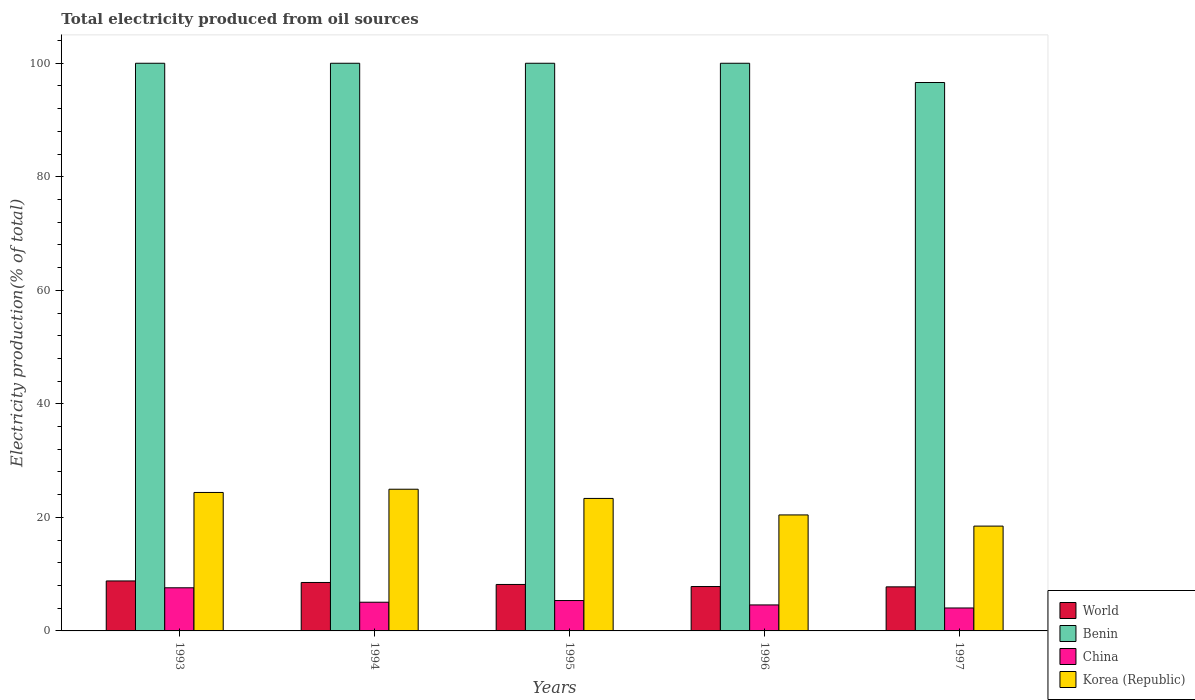How many different coloured bars are there?
Your response must be concise. 4. How many groups of bars are there?
Offer a very short reply. 5. Are the number of bars per tick equal to the number of legend labels?
Provide a short and direct response. Yes. Are the number of bars on each tick of the X-axis equal?
Offer a very short reply. Yes. How many bars are there on the 4th tick from the left?
Your response must be concise. 4. How many bars are there on the 2nd tick from the right?
Provide a succinct answer. 4. What is the label of the 3rd group of bars from the left?
Ensure brevity in your answer.  1995. What is the total electricity produced in Korea (Republic) in 1994?
Your response must be concise. 24.96. Across all years, what is the maximum total electricity produced in World?
Your answer should be compact. 8.8. Across all years, what is the minimum total electricity produced in Benin?
Provide a succinct answer. 96.61. In which year was the total electricity produced in China maximum?
Make the answer very short. 1993. In which year was the total electricity produced in Benin minimum?
Your answer should be very brief. 1997. What is the total total electricity produced in Korea (Republic) in the graph?
Give a very brief answer. 111.59. What is the difference between the total electricity produced in Korea (Republic) in 1995 and that in 1996?
Your response must be concise. 2.91. What is the difference between the total electricity produced in World in 1994 and the total electricity produced in China in 1995?
Keep it short and to the point. 3.18. What is the average total electricity produced in World per year?
Make the answer very short. 8.22. In the year 1996, what is the difference between the total electricity produced in Benin and total electricity produced in China?
Ensure brevity in your answer.  95.42. In how many years, is the total electricity produced in World greater than 76 %?
Give a very brief answer. 0. What is the ratio of the total electricity produced in China in 1995 to that in 1996?
Make the answer very short. 1.17. Is the difference between the total electricity produced in Benin in 1993 and 1995 greater than the difference between the total electricity produced in China in 1993 and 1995?
Your answer should be compact. No. What is the difference between the highest and the lowest total electricity produced in China?
Your answer should be compact. 3.55. In how many years, is the total electricity produced in World greater than the average total electricity produced in World taken over all years?
Offer a terse response. 2. Is the sum of the total electricity produced in World in 1993 and 1995 greater than the maximum total electricity produced in Korea (Republic) across all years?
Give a very brief answer. No. What does the 4th bar from the left in 1996 represents?
Your answer should be compact. Korea (Republic). Is it the case that in every year, the sum of the total electricity produced in World and total electricity produced in China is greater than the total electricity produced in Benin?
Provide a succinct answer. No. Are all the bars in the graph horizontal?
Keep it short and to the point. No. How many years are there in the graph?
Offer a very short reply. 5. What is the difference between two consecutive major ticks on the Y-axis?
Keep it short and to the point. 20. Does the graph contain any zero values?
Your answer should be compact. No. Does the graph contain grids?
Ensure brevity in your answer.  No. How many legend labels are there?
Your answer should be compact. 4. What is the title of the graph?
Your answer should be compact. Total electricity produced from oil sources. What is the Electricity production(% of total) in World in 1993?
Offer a very short reply. 8.8. What is the Electricity production(% of total) in China in 1993?
Keep it short and to the point. 7.6. What is the Electricity production(% of total) of Korea (Republic) in 1993?
Offer a very short reply. 24.39. What is the Electricity production(% of total) of World in 1994?
Your response must be concise. 8.53. What is the Electricity production(% of total) of China in 1994?
Provide a succinct answer. 5.05. What is the Electricity production(% of total) of Korea (Republic) in 1994?
Make the answer very short. 24.96. What is the Electricity production(% of total) in World in 1995?
Offer a terse response. 8.18. What is the Electricity production(% of total) of Benin in 1995?
Offer a terse response. 100. What is the Electricity production(% of total) in China in 1995?
Provide a succinct answer. 5.35. What is the Electricity production(% of total) of Korea (Republic) in 1995?
Your response must be concise. 23.34. What is the Electricity production(% of total) in World in 1996?
Your answer should be compact. 7.82. What is the Electricity production(% of total) of Benin in 1996?
Provide a succinct answer. 100. What is the Electricity production(% of total) of China in 1996?
Give a very brief answer. 4.58. What is the Electricity production(% of total) of Korea (Republic) in 1996?
Your answer should be very brief. 20.43. What is the Electricity production(% of total) in World in 1997?
Keep it short and to the point. 7.76. What is the Electricity production(% of total) in Benin in 1997?
Ensure brevity in your answer.  96.61. What is the Electricity production(% of total) of China in 1997?
Keep it short and to the point. 4.04. What is the Electricity production(% of total) of Korea (Republic) in 1997?
Provide a succinct answer. 18.47. Across all years, what is the maximum Electricity production(% of total) in World?
Your answer should be compact. 8.8. Across all years, what is the maximum Electricity production(% of total) in Benin?
Ensure brevity in your answer.  100. Across all years, what is the maximum Electricity production(% of total) in China?
Ensure brevity in your answer.  7.6. Across all years, what is the maximum Electricity production(% of total) of Korea (Republic)?
Offer a terse response. 24.96. Across all years, what is the minimum Electricity production(% of total) in World?
Offer a very short reply. 7.76. Across all years, what is the minimum Electricity production(% of total) in Benin?
Your answer should be compact. 96.61. Across all years, what is the minimum Electricity production(% of total) of China?
Keep it short and to the point. 4.04. Across all years, what is the minimum Electricity production(% of total) of Korea (Republic)?
Your answer should be very brief. 18.47. What is the total Electricity production(% of total) in World in the graph?
Offer a very short reply. 41.1. What is the total Electricity production(% of total) in Benin in the graph?
Provide a short and direct response. 496.61. What is the total Electricity production(% of total) of China in the graph?
Provide a succinct answer. 26.63. What is the total Electricity production(% of total) in Korea (Republic) in the graph?
Your answer should be compact. 111.59. What is the difference between the Electricity production(% of total) of World in 1993 and that in 1994?
Give a very brief answer. 0.27. What is the difference between the Electricity production(% of total) of China in 1993 and that in 1994?
Make the answer very short. 2.54. What is the difference between the Electricity production(% of total) in Korea (Republic) in 1993 and that in 1994?
Offer a terse response. -0.57. What is the difference between the Electricity production(% of total) of World in 1993 and that in 1995?
Provide a succinct answer. 0.62. What is the difference between the Electricity production(% of total) in China in 1993 and that in 1995?
Your response must be concise. 2.24. What is the difference between the Electricity production(% of total) of Korea (Republic) in 1993 and that in 1995?
Your answer should be very brief. 1.05. What is the difference between the Electricity production(% of total) in World in 1993 and that in 1996?
Offer a terse response. 0.99. What is the difference between the Electricity production(% of total) in China in 1993 and that in 1996?
Your answer should be compact. 3.02. What is the difference between the Electricity production(% of total) of Korea (Republic) in 1993 and that in 1996?
Ensure brevity in your answer.  3.96. What is the difference between the Electricity production(% of total) in World in 1993 and that in 1997?
Your response must be concise. 1.04. What is the difference between the Electricity production(% of total) of Benin in 1993 and that in 1997?
Offer a terse response. 3.39. What is the difference between the Electricity production(% of total) in China in 1993 and that in 1997?
Make the answer very short. 3.55. What is the difference between the Electricity production(% of total) in Korea (Republic) in 1993 and that in 1997?
Keep it short and to the point. 5.93. What is the difference between the Electricity production(% of total) in World in 1994 and that in 1995?
Give a very brief answer. 0.35. What is the difference between the Electricity production(% of total) of Benin in 1994 and that in 1995?
Make the answer very short. 0. What is the difference between the Electricity production(% of total) of China in 1994 and that in 1995?
Offer a very short reply. -0.3. What is the difference between the Electricity production(% of total) in Korea (Republic) in 1994 and that in 1995?
Your answer should be very brief. 1.62. What is the difference between the Electricity production(% of total) in World in 1994 and that in 1996?
Your answer should be very brief. 0.72. What is the difference between the Electricity production(% of total) of Benin in 1994 and that in 1996?
Your response must be concise. 0. What is the difference between the Electricity production(% of total) of China in 1994 and that in 1996?
Keep it short and to the point. 0.47. What is the difference between the Electricity production(% of total) of Korea (Republic) in 1994 and that in 1996?
Ensure brevity in your answer.  4.53. What is the difference between the Electricity production(% of total) of World in 1994 and that in 1997?
Provide a succinct answer. 0.77. What is the difference between the Electricity production(% of total) in Benin in 1994 and that in 1997?
Provide a short and direct response. 3.39. What is the difference between the Electricity production(% of total) in China in 1994 and that in 1997?
Make the answer very short. 1.01. What is the difference between the Electricity production(% of total) in Korea (Republic) in 1994 and that in 1997?
Ensure brevity in your answer.  6.5. What is the difference between the Electricity production(% of total) in World in 1995 and that in 1996?
Your answer should be very brief. 0.37. What is the difference between the Electricity production(% of total) of China in 1995 and that in 1996?
Give a very brief answer. 0.77. What is the difference between the Electricity production(% of total) in Korea (Republic) in 1995 and that in 1996?
Provide a short and direct response. 2.91. What is the difference between the Electricity production(% of total) of World in 1995 and that in 1997?
Give a very brief answer. 0.42. What is the difference between the Electricity production(% of total) in Benin in 1995 and that in 1997?
Your answer should be very brief. 3.39. What is the difference between the Electricity production(% of total) in China in 1995 and that in 1997?
Offer a terse response. 1.31. What is the difference between the Electricity production(% of total) of Korea (Republic) in 1995 and that in 1997?
Keep it short and to the point. 4.88. What is the difference between the Electricity production(% of total) in World in 1996 and that in 1997?
Offer a very short reply. 0.05. What is the difference between the Electricity production(% of total) in Benin in 1996 and that in 1997?
Ensure brevity in your answer.  3.39. What is the difference between the Electricity production(% of total) of China in 1996 and that in 1997?
Give a very brief answer. 0.54. What is the difference between the Electricity production(% of total) in Korea (Republic) in 1996 and that in 1997?
Make the answer very short. 1.97. What is the difference between the Electricity production(% of total) of World in 1993 and the Electricity production(% of total) of Benin in 1994?
Your answer should be very brief. -91.2. What is the difference between the Electricity production(% of total) of World in 1993 and the Electricity production(% of total) of China in 1994?
Provide a short and direct response. 3.75. What is the difference between the Electricity production(% of total) of World in 1993 and the Electricity production(% of total) of Korea (Republic) in 1994?
Make the answer very short. -16.16. What is the difference between the Electricity production(% of total) of Benin in 1993 and the Electricity production(% of total) of China in 1994?
Make the answer very short. 94.95. What is the difference between the Electricity production(% of total) of Benin in 1993 and the Electricity production(% of total) of Korea (Republic) in 1994?
Offer a terse response. 75.04. What is the difference between the Electricity production(% of total) in China in 1993 and the Electricity production(% of total) in Korea (Republic) in 1994?
Ensure brevity in your answer.  -17.36. What is the difference between the Electricity production(% of total) in World in 1993 and the Electricity production(% of total) in Benin in 1995?
Provide a succinct answer. -91.2. What is the difference between the Electricity production(% of total) in World in 1993 and the Electricity production(% of total) in China in 1995?
Provide a short and direct response. 3.45. What is the difference between the Electricity production(% of total) of World in 1993 and the Electricity production(% of total) of Korea (Republic) in 1995?
Keep it short and to the point. -14.54. What is the difference between the Electricity production(% of total) in Benin in 1993 and the Electricity production(% of total) in China in 1995?
Provide a short and direct response. 94.65. What is the difference between the Electricity production(% of total) of Benin in 1993 and the Electricity production(% of total) of Korea (Republic) in 1995?
Provide a succinct answer. 76.66. What is the difference between the Electricity production(% of total) of China in 1993 and the Electricity production(% of total) of Korea (Republic) in 1995?
Give a very brief answer. -15.74. What is the difference between the Electricity production(% of total) in World in 1993 and the Electricity production(% of total) in Benin in 1996?
Ensure brevity in your answer.  -91.2. What is the difference between the Electricity production(% of total) in World in 1993 and the Electricity production(% of total) in China in 1996?
Provide a succinct answer. 4.22. What is the difference between the Electricity production(% of total) in World in 1993 and the Electricity production(% of total) in Korea (Republic) in 1996?
Offer a terse response. -11.63. What is the difference between the Electricity production(% of total) of Benin in 1993 and the Electricity production(% of total) of China in 1996?
Your response must be concise. 95.42. What is the difference between the Electricity production(% of total) in Benin in 1993 and the Electricity production(% of total) in Korea (Republic) in 1996?
Your answer should be very brief. 79.57. What is the difference between the Electricity production(% of total) in China in 1993 and the Electricity production(% of total) in Korea (Republic) in 1996?
Make the answer very short. -12.84. What is the difference between the Electricity production(% of total) in World in 1993 and the Electricity production(% of total) in Benin in 1997?
Make the answer very short. -87.81. What is the difference between the Electricity production(% of total) in World in 1993 and the Electricity production(% of total) in China in 1997?
Keep it short and to the point. 4.76. What is the difference between the Electricity production(% of total) of World in 1993 and the Electricity production(% of total) of Korea (Republic) in 1997?
Your answer should be compact. -9.66. What is the difference between the Electricity production(% of total) in Benin in 1993 and the Electricity production(% of total) in China in 1997?
Your response must be concise. 95.96. What is the difference between the Electricity production(% of total) of Benin in 1993 and the Electricity production(% of total) of Korea (Republic) in 1997?
Your answer should be compact. 81.53. What is the difference between the Electricity production(% of total) in China in 1993 and the Electricity production(% of total) in Korea (Republic) in 1997?
Give a very brief answer. -10.87. What is the difference between the Electricity production(% of total) of World in 1994 and the Electricity production(% of total) of Benin in 1995?
Provide a short and direct response. -91.47. What is the difference between the Electricity production(% of total) in World in 1994 and the Electricity production(% of total) in China in 1995?
Give a very brief answer. 3.18. What is the difference between the Electricity production(% of total) in World in 1994 and the Electricity production(% of total) in Korea (Republic) in 1995?
Make the answer very short. -14.81. What is the difference between the Electricity production(% of total) in Benin in 1994 and the Electricity production(% of total) in China in 1995?
Offer a terse response. 94.65. What is the difference between the Electricity production(% of total) of Benin in 1994 and the Electricity production(% of total) of Korea (Republic) in 1995?
Provide a short and direct response. 76.66. What is the difference between the Electricity production(% of total) in China in 1994 and the Electricity production(% of total) in Korea (Republic) in 1995?
Give a very brief answer. -18.29. What is the difference between the Electricity production(% of total) in World in 1994 and the Electricity production(% of total) in Benin in 1996?
Ensure brevity in your answer.  -91.47. What is the difference between the Electricity production(% of total) in World in 1994 and the Electricity production(% of total) in China in 1996?
Your response must be concise. 3.95. What is the difference between the Electricity production(% of total) in World in 1994 and the Electricity production(% of total) in Korea (Republic) in 1996?
Offer a very short reply. -11.9. What is the difference between the Electricity production(% of total) in Benin in 1994 and the Electricity production(% of total) in China in 1996?
Ensure brevity in your answer.  95.42. What is the difference between the Electricity production(% of total) in Benin in 1994 and the Electricity production(% of total) in Korea (Republic) in 1996?
Give a very brief answer. 79.57. What is the difference between the Electricity production(% of total) of China in 1994 and the Electricity production(% of total) of Korea (Republic) in 1996?
Keep it short and to the point. -15.38. What is the difference between the Electricity production(% of total) of World in 1994 and the Electricity production(% of total) of Benin in 1997?
Offer a terse response. -88.08. What is the difference between the Electricity production(% of total) in World in 1994 and the Electricity production(% of total) in China in 1997?
Your answer should be very brief. 4.49. What is the difference between the Electricity production(% of total) of World in 1994 and the Electricity production(% of total) of Korea (Republic) in 1997?
Offer a very short reply. -9.93. What is the difference between the Electricity production(% of total) in Benin in 1994 and the Electricity production(% of total) in China in 1997?
Your answer should be very brief. 95.96. What is the difference between the Electricity production(% of total) of Benin in 1994 and the Electricity production(% of total) of Korea (Republic) in 1997?
Your answer should be compact. 81.53. What is the difference between the Electricity production(% of total) of China in 1994 and the Electricity production(% of total) of Korea (Republic) in 1997?
Your answer should be compact. -13.41. What is the difference between the Electricity production(% of total) of World in 1995 and the Electricity production(% of total) of Benin in 1996?
Make the answer very short. -91.82. What is the difference between the Electricity production(% of total) of World in 1995 and the Electricity production(% of total) of China in 1996?
Ensure brevity in your answer.  3.6. What is the difference between the Electricity production(% of total) in World in 1995 and the Electricity production(% of total) in Korea (Republic) in 1996?
Your answer should be very brief. -12.25. What is the difference between the Electricity production(% of total) in Benin in 1995 and the Electricity production(% of total) in China in 1996?
Offer a terse response. 95.42. What is the difference between the Electricity production(% of total) in Benin in 1995 and the Electricity production(% of total) in Korea (Republic) in 1996?
Keep it short and to the point. 79.57. What is the difference between the Electricity production(% of total) in China in 1995 and the Electricity production(% of total) in Korea (Republic) in 1996?
Offer a terse response. -15.08. What is the difference between the Electricity production(% of total) in World in 1995 and the Electricity production(% of total) in Benin in 1997?
Keep it short and to the point. -88.43. What is the difference between the Electricity production(% of total) of World in 1995 and the Electricity production(% of total) of China in 1997?
Your response must be concise. 4.14. What is the difference between the Electricity production(% of total) of World in 1995 and the Electricity production(% of total) of Korea (Republic) in 1997?
Provide a succinct answer. -10.28. What is the difference between the Electricity production(% of total) in Benin in 1995 and the Electricity production(% of total) in China in 1997?
Offer a terse response. 95.96. What is the difference between the Electricity production(% of total) of Benin in 1995 and the Electricity production(% of total) of Korea (Republic) in 1997?
Provide a succinct answer. 81.53. What is the difference between the Electricity production(% of total) in China in 1995 and the Electricity production(% of total) in Korea (Republic) in 1997?
Offer a very short reply. -13.11. What is the difference between the Electricity production(% of total) of World in 1996 and the Electricity production(% of total) of Benin in 1997?
Provide a succinct answer. -88.79. What is the difference between the Electricity production(% of total) of World in 1996 and the Electricity production(% of total) of China in 1997?
Offer a terse response. 3.77. What is the difference between the Electricity production(% of total) in World in 1996 and the Electricity production(% of total) in Korea (Republic) in 1997?
Provide a succinct answer. -10.65. What is the difference between the Electricity production(% of total) of Benin in 1996 and the Electricity production(% of total) of China in 1997?
Offer a very short reply. 95.96. What is the difference between the Electricity production(% of total) of Benin in 1996 and the Electricity production(% of total) of Korea (Republic) in 1997?
Keep it short and to the point. 81.53. What is the difference between the Electricity production(% of total) in China in 1996 and the Electricity production(% of total) in Korea (Republic) in 1997?
Provide a short and direct response. -13.89. What is the average Electricity production(% of total) in World per year?
Offer a very short reply. 8.22. What is the average Electricity production(% of total) in Benin per year?
Your answer should be very brief. 99.32. What is the average Electricity production(% of total) of China per year?
Provide a short and direct response. 5.33. What is the average Electricity production(% of total) of Korea (Republic) per year?
Your answer should be very brief. 22.32. In the year 1993, what is the difference between the Electricity production(% of total) of World and Electricity production(% of total) of Benin?
Provide a short and direct response. -91.2. In the year 1993, what is the difference between the Electricity production(% of total) of World and Electricity production(% of total) of China?
Keep it short and to the point. 1.21. In the year 1993, what is the difference between the Electricity production(% of total) of World and Electricity production(% of total) of Korea (Republic)?
Offer a very short reply. -15.59. In the year 1993, what is the difference between the Electricity production(% of total) in Benin and Electricity production(% of total) in China?
Offer a terse response. 92.4. In the year 1993, what is the difference between the Electricity production(% of total) of Benin and Electricity production(% of total) of Korea (Republic)?
Offer a very short reply. 75.61. In the year 1993, what is the difference between the Electricity production(% of total) in China and Electricity production(% of total) in Korea (Republic)?
Keep it short and to the point. -16.79. In the year 1994, what is the difference between the Electricity production(% of total) in World and Electricity production(% of total) in Benin?
Offer a very short reply. -91.47. In the year 1994, what is the difference between the Electricity production(% of total) in World and Electricity production(% of total) in China?
Your response must be concise. 3.48. In the year 1994, what is the difference between the Electricity production(% of total) in World and Electricity production(% of total) in Korea (Republic)?
Give a very brief answer. -16.43. In the year 1994, what is the difference between the Electricity production(% of total) of Benin and Electricity production(% of total) of China?
Your answer should be compact. 94.95. In the year 1994, what is the difference between the Electricity production(% of total) in Benin and Electricity production(% of total) in Korea (Republic)?
Keep it short and to the point. 75.04. In the year 1994, what is the difference between the Electricity production(% of total) of China and Electricity production(% of total) of Korea (Republic)?
Provide a short and direct response. -19.91. In the year 1995, what is the difference between the Electricity production(% of total) in World and Electricity production(% of total) in Benin?
Your response must be concise. -91.82. In the year 1995, what is the difference between the Electricity production(% of total) of World and Electricity production(% of total) of China?
Offer a very short reply. 2.83. In the year 1995, what is the difference between the Electricity production(% of total) of World and Electricity production(% of total) of Korea (Republic)?
Your response must be concise. -15.16. In the year 1995, what is the difference between the Electricity production(% of total) in Benin and Electricity production(% of total) in China?
Offer a terse response. 94.65. In the year 1995, what is the difference between the Electricity production(% of total) of Benin and Electricity production(% of total) of Korea (Republic)?
Make the answer very short. 76.66. In the year 1995, what is the difference between the Electricity production(% of total) in China and Electricity production(% of total) in Korea (Republic)?
Offer a terse response. -17.99. In the year 1996, what is the difference between the Electricity production(% of total) in World and Electricity production(% of total) in Benin?
Provide a short and direct response. -92.18. In the year 1996, what is the difference between the Electricity production(% of total) in World and Electricity production(% of total) in China?
Your response must be concise. 3.24. In the year 1996, what is the difference between the Electricity production(% of total) of World and Electricity production(% of total) of Korea (Republic)?
Offer a terse response. -12.62. In the year 1996, what is the difference between the Electricity production(% of total) of Benin and Electricity production(% of total) of China?
Make the answer very short. 95.42. In the year 1996, what is the difference between the Electricity production(% of total) in Benin and Electricity production(% of total) in Korea (Republic)?
Your response must be concise. 79.57. In the year 1996, what is the difference between the Electricity production(% of total) of China and Electricity production(% of total) of Korea (Republic)?
Ensure brevity in your answer.  -15.85. In the year 1997, what is the difference between the Electricity production(% of total) in World and Electricity production(% of total) in Benin?
Ensure brevity in your answer.  -88.85. In the year 1997, what is the difference between the Electricity production(% of total) in World and Electricity production(% of total) in China?
Keep it short and to the point. 3.72. In the year 1997, what is the difference between the Electricity production(% of total) of World and Electricity production(% of total) of Korea (Republic)?
Offer a terse response. -10.7. In the year 1997, what is the difference between the Electricity production(% of total) in Benin and Electricity production(% of total) in China?
Ensure brevity in your answer.  92.57. In the year 1997, what is the difference between the Electricity production(% of total) of Benin and Electricity production(% of total) of Korea (Republic)?
Your response must be concise. 78.14. In the year 1997, what is the difference between the Electricity production(% of total) of China and Electricity production(% of total) of Korea (Republic)?
Offer a very short reply. -14.42. What is the ratio of the Electricity production(% of total) of World in 1993 to that in 1994?
Your response must be concise. 1.03. What is the ratio of the Electricity production(% of total) in China in 1993 to that in 1994?
Keep it short and to the point. 1.5. What is the ratio of the Electricity production(% of total) in Korea (Republic) in 1993 to that in 1994?
Give a very brief answer. 0.98. What is the ratio of the Electricity production(% of total) of World in 1993 to that in 1995?
Give a very brief answer. 1.08. What is the ratio of the Electricity production(% of total) in China in 1993 to that in 1995?
Give a very brief answer. 1.42. What is the ratio of the Electricity production(% of total) in Korea (Republic) in 1993 to that in 1995?
Ensure brevity in your answer.  1.04. What is the ratio of the Electricity production(% of total) of World in 1993 to that in 1996?
Keep it short and to the point. 1.13. What is the ratio of the Electricity production(% of total) of China in 1993 to that in 1996?
Give a very brief answer. 1.66. What is the ratio of the Electricity production(% of total) in Korea (Republic) in 1993 to that in 1996?
Your answer should be compact. 1.19. What is the ratio of the Electricity production(% of total) of World in 1993 to that in 1997?
Give a very brief answer. 1.13. What is the ratio of the Electricity production(% of total) in Benin in 1993 to that in 1997?
Provide a short and direct response. 1.04. What is the ratio of the Electricity production(% of total) in China in 1993 to that in 1997?
Keep it short and to the point. 1.88. What is the ratio of the Electricity production(% of total) of Korea (Republic) in 1993 to that in 1997?
Provide a short and direct response. 1.32. What is the ratio of the Electricity production(% of total) of World in 1994 to that in 1995?
Your response must be concise. 1.04. What is the ratio of the Electricity production(% of total) of China in 1994 to that in 1995?
Ensure brevity in your answer.  0.94. What is the ratio of the Electricity production(% of total) of Korea (Republic) in 1994 to that in 1995?
Your response must be concise. 1.07. What is the ratio of the Electricity production(% of total) in World in 1994 to that in 1996?
Make the answer very short. 1.09. What is the ratio of the Electricity production(% of total) in China in 1994 to that in 1996?
Your response must be concise. 1.1. What is the ratio of the Electricity production(% of total) of Korea (Republic) in 1994 to that in 1996?
Your response must be concise. 1.22. What is the ratio of the Electricity production(% of total) in World in 1994 to that in 1997?
Offer a very short reply. 1.1. What is the ratio of the Electricity production(% of total) in Benin in 1994 to that in 1997?
Your answer should be compact. 1.04. What is the ratio of the Electricity production(% of total) in China in 1994 to that in 1997?
Make the answer very short. 1.25. What is the ratio of the Electricity production(% of total) in Korea (Republic) in 1994 to that in 1997?
Provide a short and direct response. 1.35. What is the ratio of the Electricity production(% of total) of World in 1995 to that in 1996?
Keep it short and to the point. 1.05. What is the ratio of the Electricity production(% of total) in Benin in 1995 to that in 1996?
Give a very brief answer. 1. What is the ratio of the Electricity production(% of total) in China in 1995 to that in 1996?
Your answer should be compact. 1.17. What is the ratio of the Electricity production(% of total) of Korea (Republic) in 1995 to that in 1996?
Ensure brevity in your answer.  1.14. What is the ratio of the Electricity production(% of total) of World in 1995 to that in 1997?
Offer a terse response. 1.05. What is the ratio of the Electricity production(% of total) in Benin in 1995 to that in 1997?
Your response must be concise. 1.04. What is the ratio of the Electricity production(% of total) of China in 1995 to that in 1997?
Your response must be concise. 1.32. What is the ratio of the Electricity production(% of total) in Korea (Republic) in 1995 to that in 1997?
Your response must be concise. 1.26. What is the ratio of the Electricity production(% of total) in World in 1996 to that in 1997?
Your response must be concise. 1.01. What is the ratio of the Electricity production(% of total) of Benin in 1996 to that in 1997?
Offer a terse response. 1.04. What is the ratio of the Electricity production(% of total) of China in 1996 to that in 1997?
Your answer should be compact. 1.13. What is the ratio of the Electricity production(% of total) in Korea (Republic) in 1996 to that in 1997?
Offer a terse response. 1.11. What is the difference between the highest and the second highest Electricity production(% of total) of World?
Provide a succinct answer. 0.27. What is the difference between the highest and the second highest Electricity production(% of total) in Benin?
Keep it short and to the point. 0. What is the difference between the highest and the second highest Electricity production(% of total) in China?
Your answer should be compact. 2.24. What is the difference between the highest and the second highest Electricity production(% of total) of Korea (Republic)?
Your response must be concise. 0.57. What is the difference between the highest and the lowest Electricity production(% of total) in World?
Provide a short and direct response. 1.04. What is the difference between the highest and the lowest Electricity production(% of total) in Benin?
Ensure brevity in your answer.  3.39. What is the difference between the highest and the lowest Electricity production(% of total) in China?
Your answer should be very brief. 3.55. What is the difference between the highest and the lowest Electricity production(% of total) of Korea (Republic)?
Your answer should be compact. 6.5. 